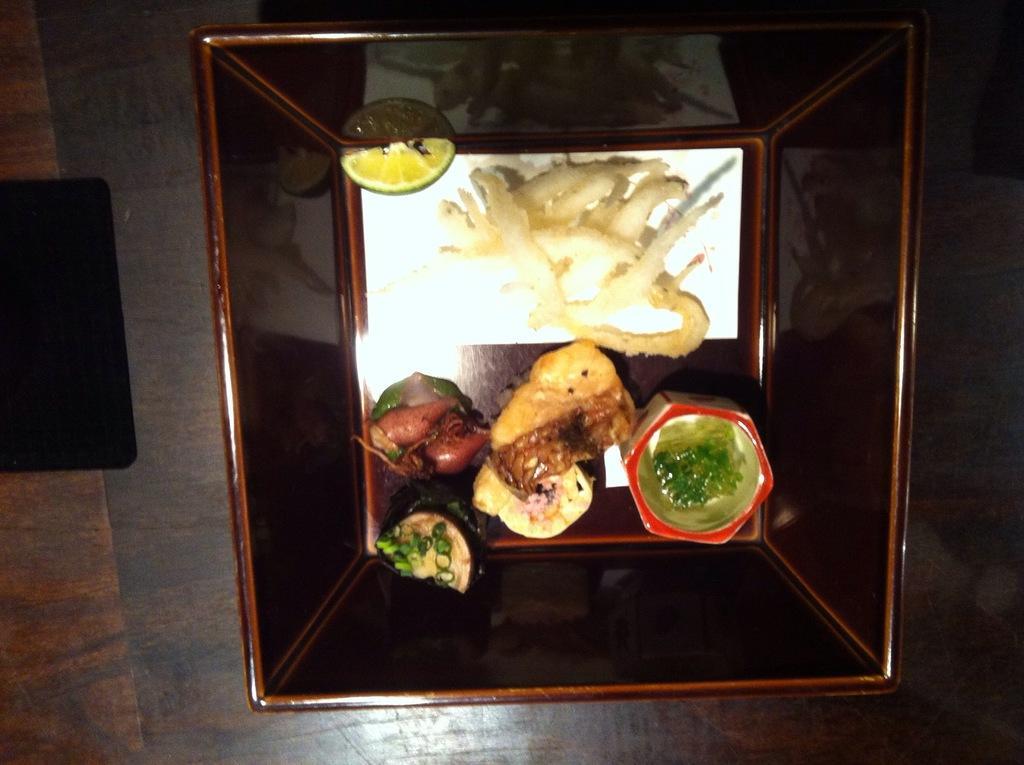Please provide a concise description of this image. In the image there is a bowl with lemon slice and some other food items in it. On the left side of the image there is a black object on the wooden surface. 